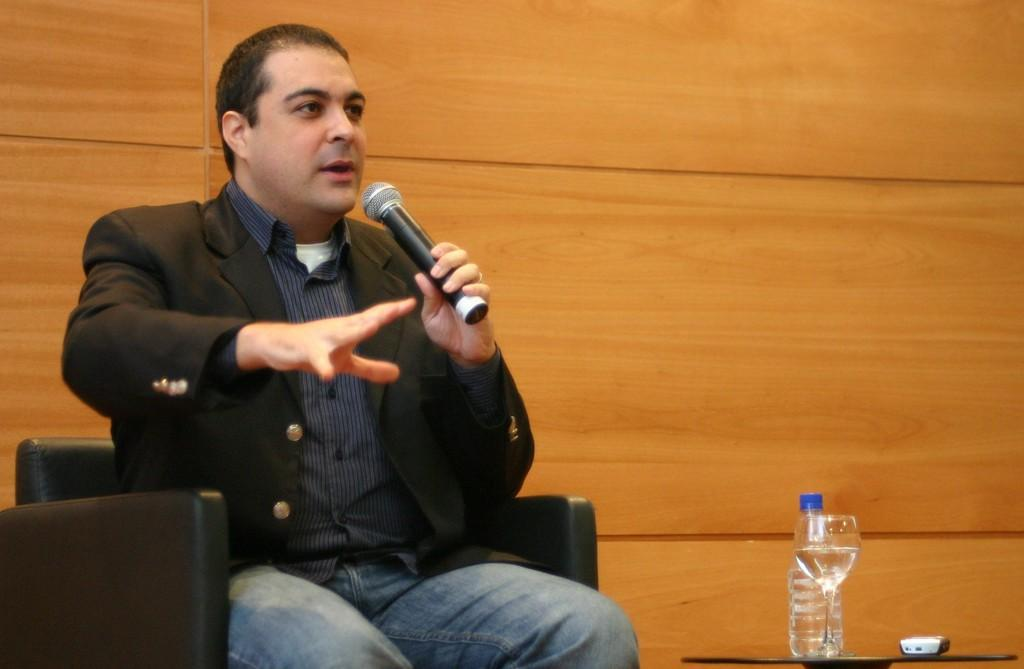What is the man in the image doing? The man is seated on a chair in the image. What is the man holding in the image? The man is holding a microphone. What objects are in front of the man? There is a bottle and a glass in front of the man. What is on the table in front of the man? There is a mobile on the table in front of the man. Where is the cave located in the image? There is no cave present in the image. What type of toys can be seen on the table in the image? There are no toys present in the image; only a mobile is visible on the table. 